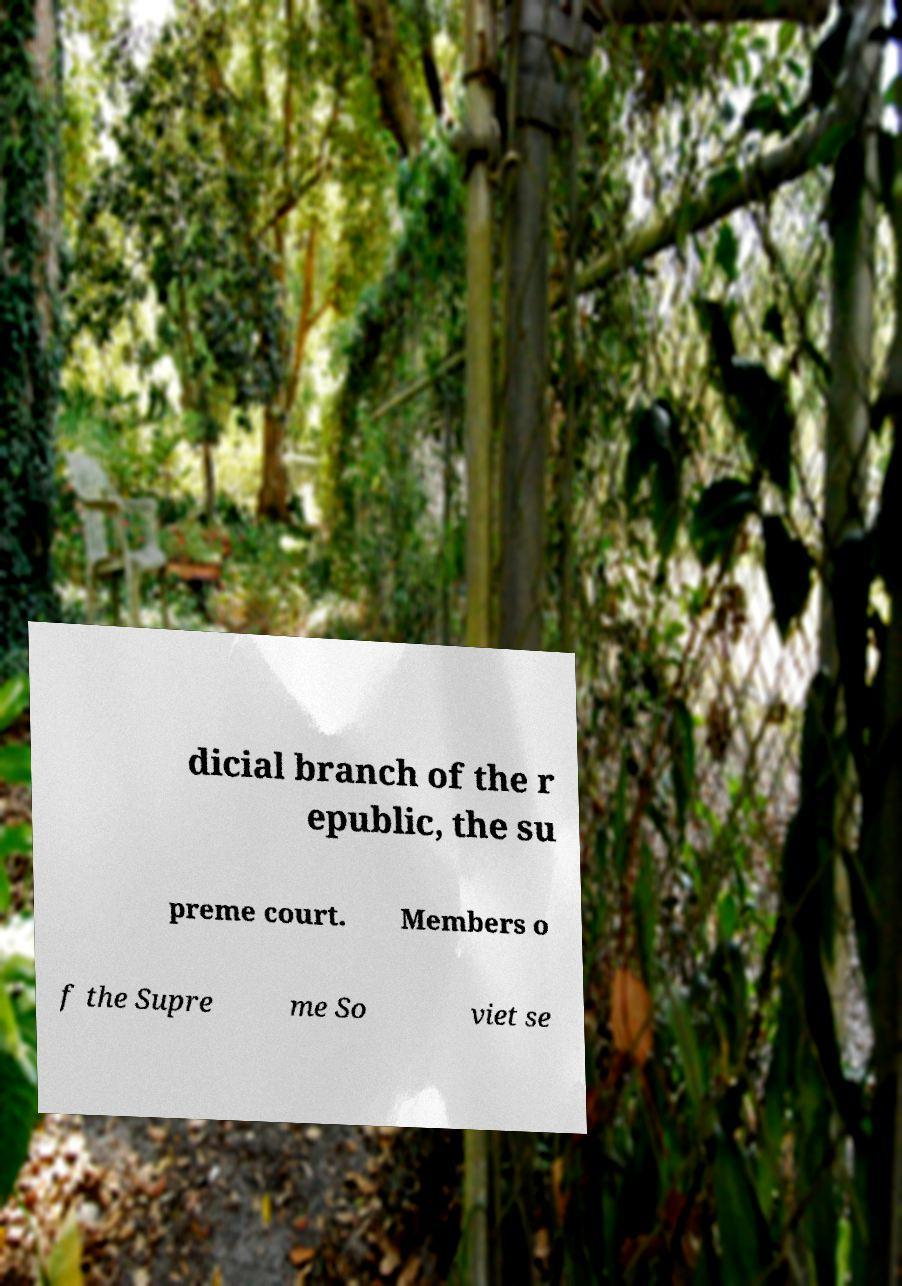Can you accurately transcribe the text from the provided image for me? dicial branch of the r epublic, the su preme court. Members o f the Supre me So viet se 